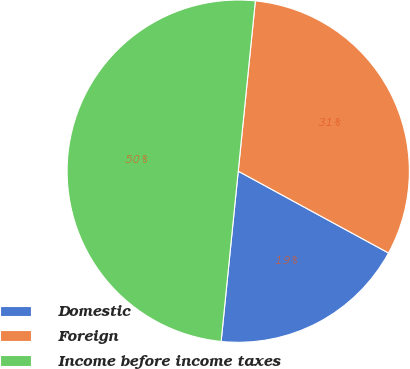<chart> <loc_0><loc_0><loc_500><loc_500><pie_chart><fcel>Domestic<fcel>Foreign<fcel>Income before income taxes<nl><fcel>18.66%<fcel>31.34%<fcel>50.0%<nl></chart> 